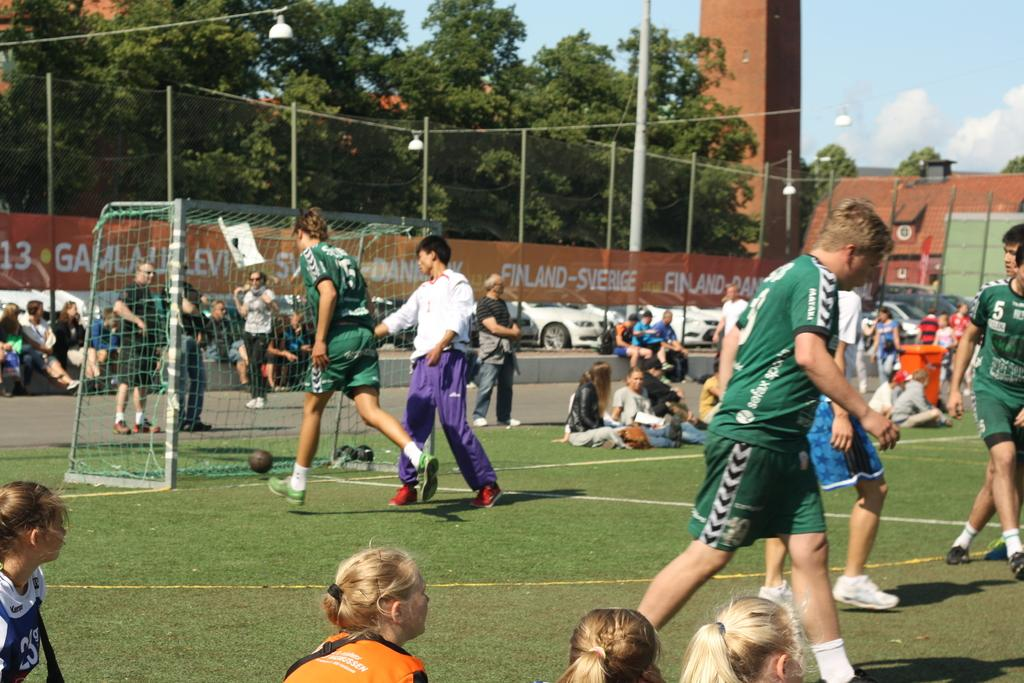<image>
Create a compact narrative representing the image presented. One of the sponsors of the field was Finland-Sverige. 